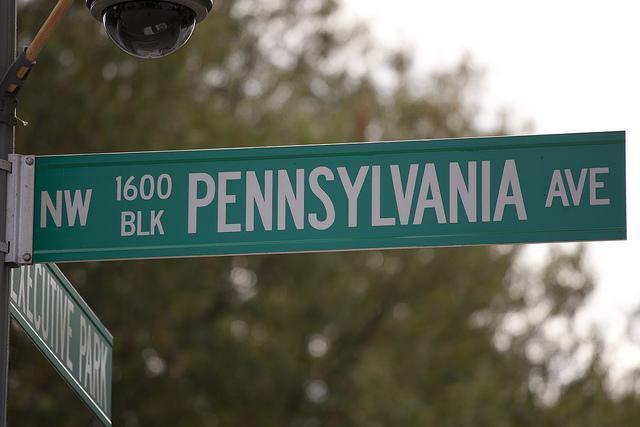How many sets of double letters are on this street sign?
Give a very brief answer. 1. 